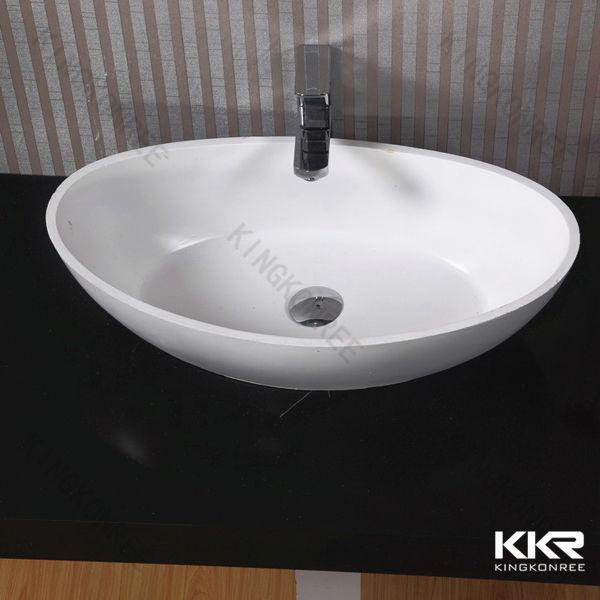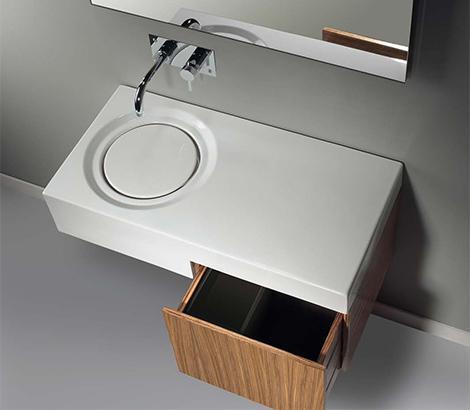The first image is the image on the left, the second image is the image on the right. For the images shown, is this caption "The sink in the image on the right is shaped like a bowl." true? Answer yes or no. No. 